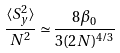<formula> <loc_0><loc_0><loc_500><loc_500>\frac { \langle S _ { y } ^ { 2 } \rangle } { N ^ { 2 } } \simeq \frac { 8 \beta _ { 0 } } { 3 ( 2 N ) ^ { 4 / 3 } }</formula> 